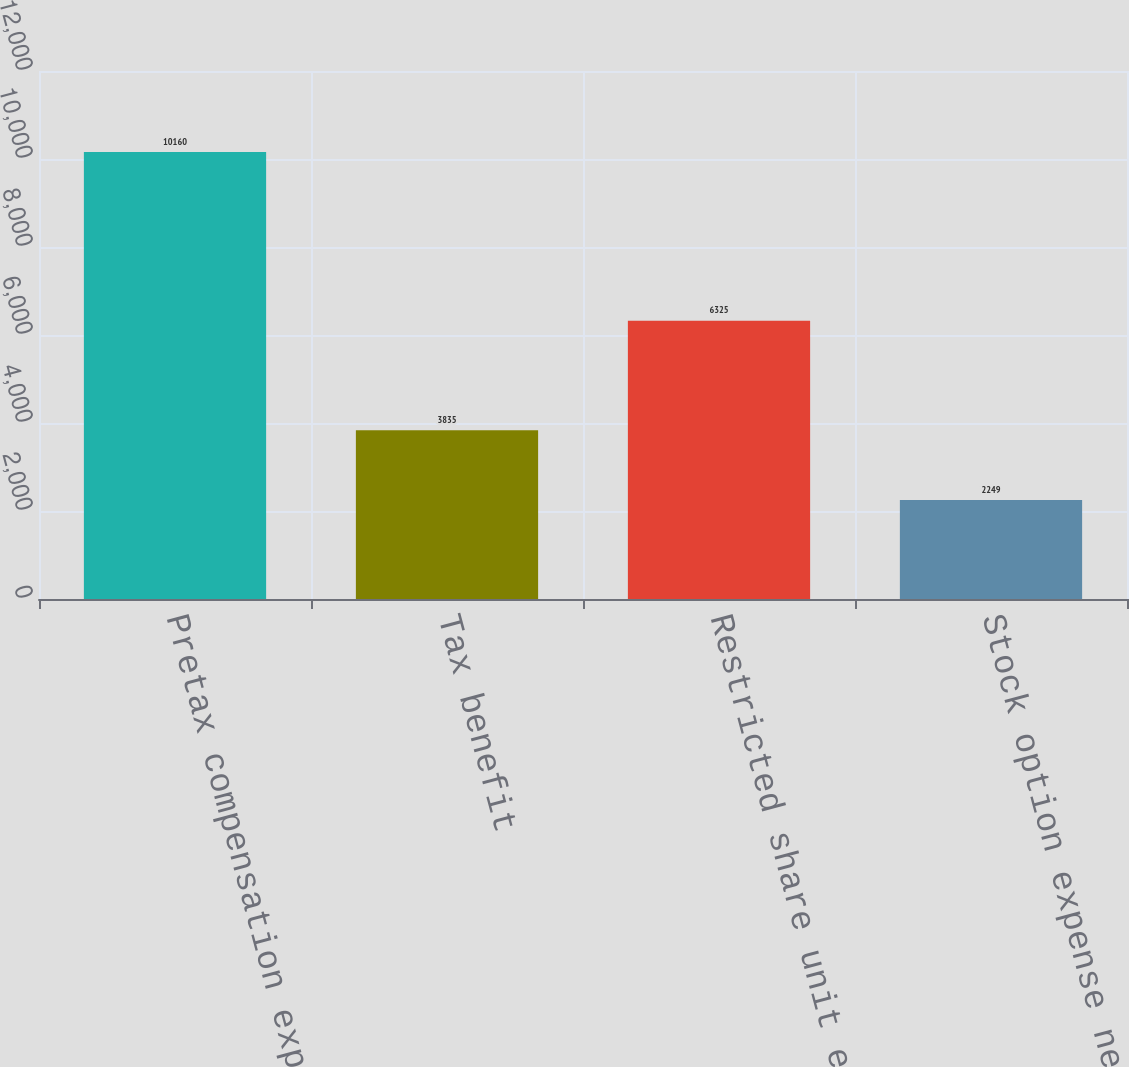<chart> <loc_0><loc_0><loc_500><loc_500><bar_chart><fcel>Pretax compensation expense<fcel>Tax benefit<fcel>Restricted share unit expense<fcel>Stock option expense net of<nl><fcel>10160<fcel>3835<fcel>6325<fcel>2249<nl></chart> 